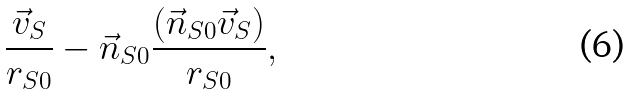Convert formula to latex. <formula><loc_0><loc_0><loc_500><loc_500>\frac { \vec { v } _ { S } } { r _ { S 0 } } - \vec { n } _ { S 0 } \frac { ( \vec { n } _ { S 0 } \vec { v } _ { S } ) } { r _ { S 0 } } ,</formula> 